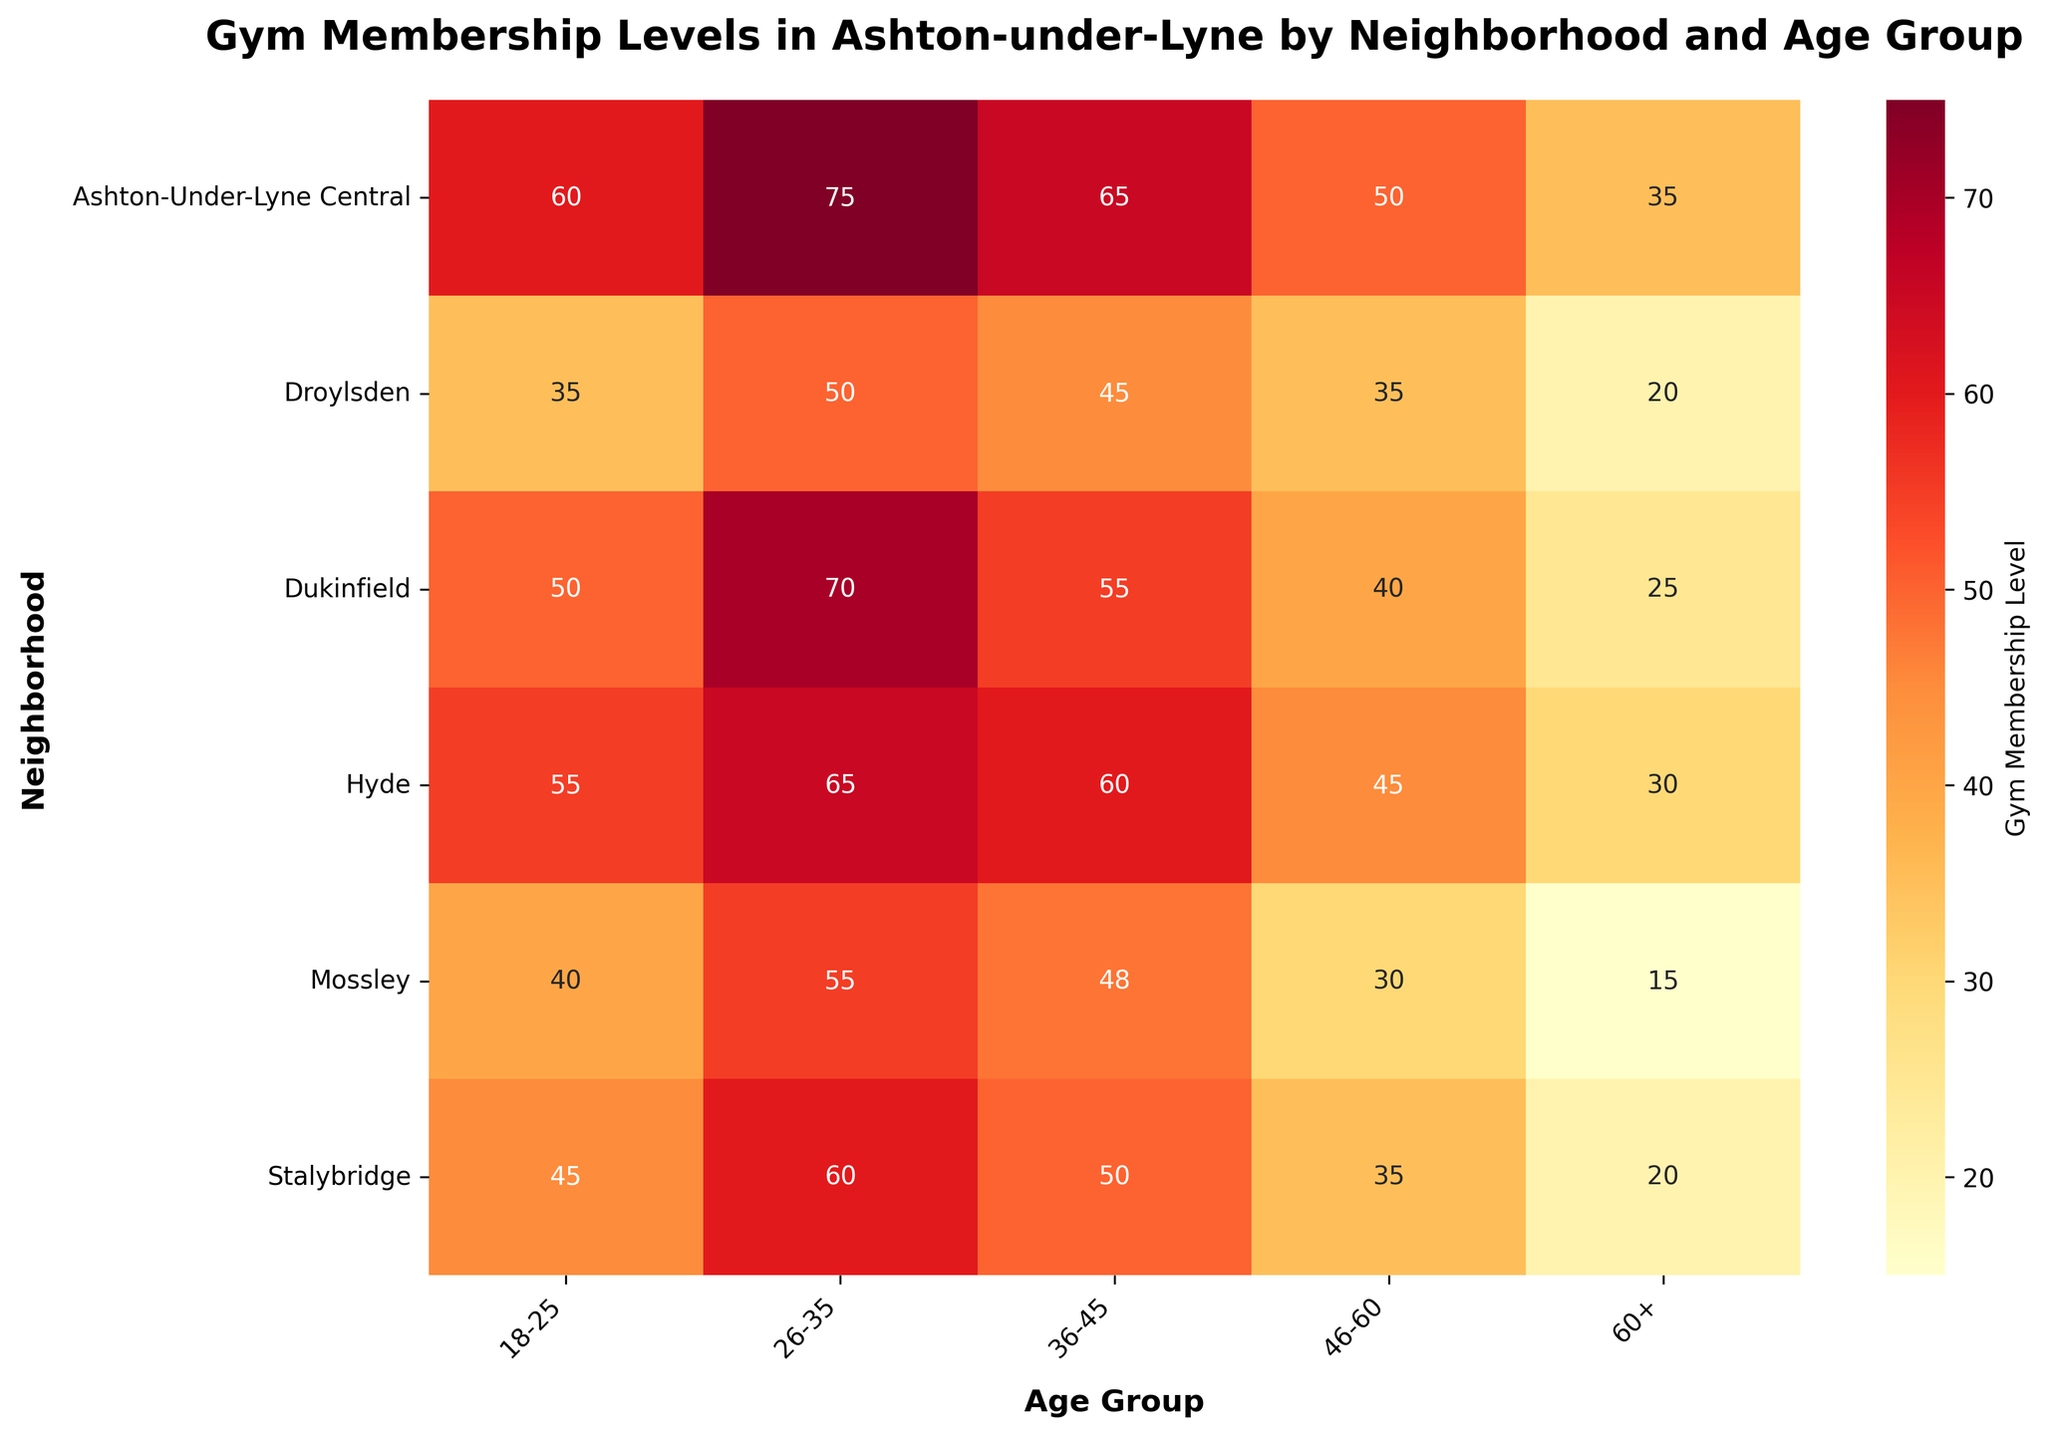What's the title of the heatmap? The title is a textual element at the top of the heatmap. It provides context and indicates what the heatmap is depicting.
Answer: Gym Membership Levels in Ashton-under-Lyne by Neighborhood and Age Group Which neighborhood has the highest gym membership level for the age group 26-35? Looking at the heatmap, the cell in the row for "Ashton-Under-Lyne Central" and column "26-35" has the highest value, which is 75.
Answer: Ashton-Under-Lyne Central What's the average gym membership level for Droylsden? Sum the values for all age groups in Droylsden (35 + 50 + 45 + 35 + 20) = 185. There are 5 age groups, so the average is 185 / 5 = 37.
Answer: 37 Which age group has the lowest gym membership level in Hyde? In Hyde's row, the lowest value is in the "60+" column, which is 30.
Answer: 60+ Are there any neighborhoods where the gym membership level for the age group 18-25 is higher than 50? Checking the 18-25 column, both Hyde (55) and Ashton-Under-Lyne Central (60) have membership levels higher than 50.
Answer: Yes, Hyde and Ashton-Under-Lyne Central What is the difference in gym membership levels between Stalybridge and Mossley for the age group 36-45? Stalybridge has a value of 50, and Mossley has 48 for the same age group. The difference is 50 - 48 = 2.
Answer: 2 What's the sum of the gym membership levels in Dukinfield across all age groups? Sum the values for Dukinfield (50 + 70 + 55 + 40 + 25) = 240.
Answer: 240 In which neighborhood do people aged 46-60 have the highest gym membership level? For the age group 46-60, the highest value is in Ashton-Under-Lyne Central, which is 50.
Answer: Ashton-Under-Lyne Central Is there any age group where Mossley has a higher membership level than Stalybridge? Comparing Mossley and Stalybridge for each age group: 18-25: 40 vs 45, 26-35: 55 vs 60, 36-45: 48 vs 50, 46-60: 30 vs 35, 60+: 15 vs 20. There is no case where Mossley has a higher level.
Answer: No 